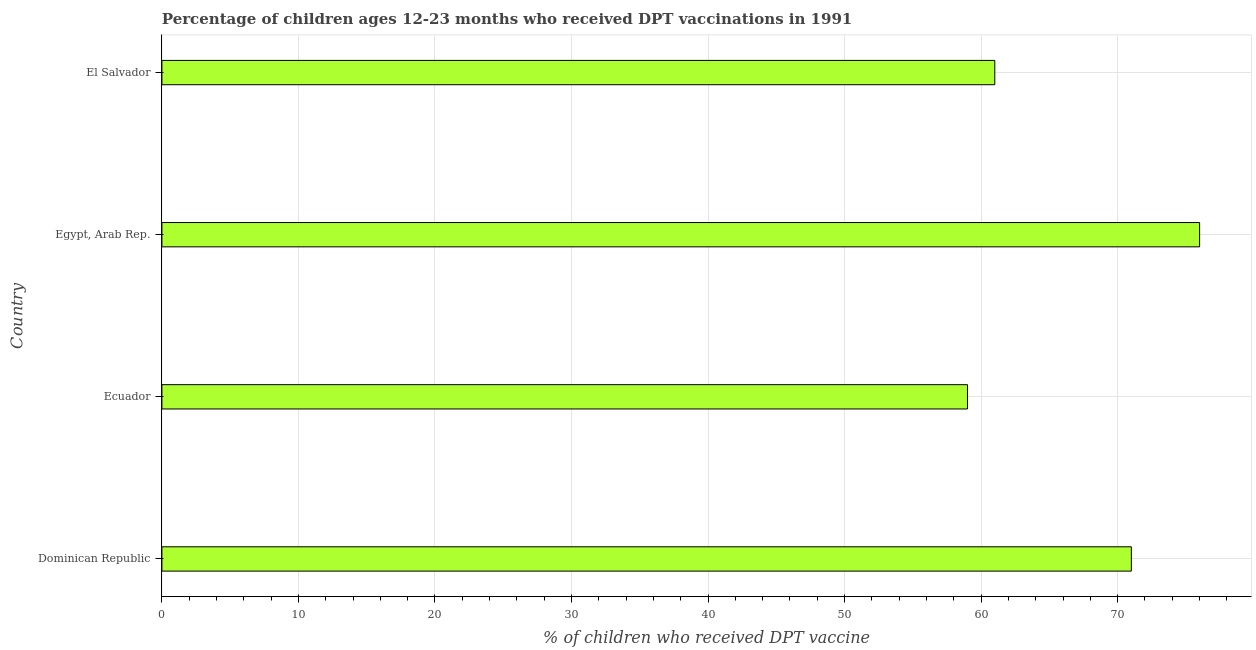Does the graph contain any zero values?
Give a very brief answer. No. Does the graph contain grids?
Keep it short and to the point. Yes. What is the title of the graph?
Your answer should be compact. Percentage of children ages 12-23 months who received DPT vaccinations in 1991. What is the label or title of the X-axis?
Your answer should be compact. % of children who received DPT vaccine. What is the label or title of the Y-axis?
Provide a succinct answer. Country. What is the percentage of children who received dpt vaccine in Dominican Republic?
Provide a succinct answer. 71. Across all countries, what is the minimum percentage of children who received dpt vaccine?
Give a very brief answer. 59. In which country was the percentage of children who received dpt vaccine maximum?
Keep it short and to the point. Egypt, Arab Rep. In which country was the percentage of children who received dpt vaccine minimum?
Keep it short and to the point. Ecuador. What is the sum of the percentage of children who received dpt vaccine?
Make the answer very short. 267. What is the difference between the percentage of children who received dpt vaccine in Dominican Republic and Egypt, Arab Rep.?
Your answer should be compact. -5. What is the average percentage of children who received dpt vaccine per country?
Provide a succinct answer. 66.75. What is the median percentage of children who received dpt vaccine?
Make the answer very short. 66. In how many countries, is the percentage of children who received dpt vaccine greater than 30 %?
Your response must be concise. 4. Is the difference between the percentage of children who received dpt vaccine in Dominican Republic and El Salvador greater than the difference between any two countries?
Your response must be concise. No. Is the sum of the percentage of children who received dpt vaccine in Egypt, Arab Rep. and El Salvador greater than the maximum percentage of children who received dpt vaccine across all countries?
Keep it short and to the point. Yes. What is the difference between the highest and the lowest percentage of children who received dpt vaccine?
Offer a terse response. 17. How many bars are there?
Offer a terse response. 4. Are all the bars in the graph horizontal?
Offer a very short reply. Yes. How many countries are there in the graph?
Ensure brevity in your answer.  4. What is the difference between two consecutive major ticks on the X-axis?
Make the answer very short. 10. Are the values on the major ticks of X-axis written in scientific E-notation?
Offer a very short reply. No. What is the % of children who received DPT vaccine in Dominican Republic?
Your answer should be compact. 71. What is the % of children who received DPT vaccine in Ecuador?
Give a very brief answer. 59. What is the difference between the % of children who received DPT vaccine in Dominican Republic and Ecuador?
Keep it short and to the point. 12. What is the difference between the % of children who received DPT vaccine in Dominican Republic and Egypt, Arab Rep.?
Keep it short and to the point. -5. What is the difference between the % of children who received DPT vaccine in Ecuador and Egypt, Arab Rep.?
Keep it short and to the point. -17. What is the difference between the % of children who received DPT vaccine in Egypt, Arab Rep. and El Salvador?
Give a very brief answer. 15. What is the ratio of the % of children who received DPT vaccine in Dominican Republic to that in Ecuador?
Keep it short and to the point. 1.2. What is the ratio of the % of children who received DPT vaccine in Dominican Republic to that in Egypt, Arab Rep.?
Give a very brief answer. 0.93. What is the ratio of the % of children who received DPT vaccine in Dominican Republic to that in El Salvador?
Your answer should be very brief. 1.16. What is the ratio of the % of children who received DPT vaccine in Ecuador to that in Egypt, Arab Rep.?
Offer a very short reply. 0.78. What is the ratio of the % of children who received DPT vaccine in Ecuador to that in El Salvador?
Your answer should be compact. 0.97. What is the ratio of the % of children who received DPT vaccine in Egypt, Arab Rep. to that in El Salvador?
Offer a very short reply. 1.25. 